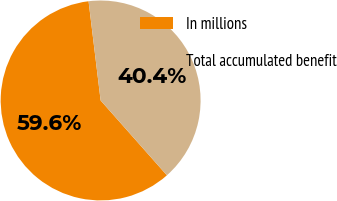Convert chart to OTSL. <chart><loc_0><loc_0><loc_500><loc_500><pie_chart><fcel>In millions<fcel>Total accumulated benefit<nl><fcel>59.61%<fcel>40.39%<nl></chart> 